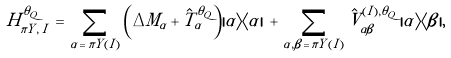<formula> <loc_0><loc_0><loc_500><loc_500>H _ { \pi Y , \, I } ^ { \theta _ { Q } } \, = \, \sum _ { \alpha \, = \, \pi Y ( I ) } \left ( \Delta M _ { \alpha } + \hat { T } _ { \alpha } ^ { \theta _ { Q } } \right ) | \alpha \rangle \langle \alpha | \, + \, \sum _ { \alpha , \beta \, = \, \pi Y ( I ) } \hat { V } _ { \alpha \beta } ^ { ( I ) , { \theta _ { Q } } } \, | \alpha \rangle \langle \beta | ,</formula> 